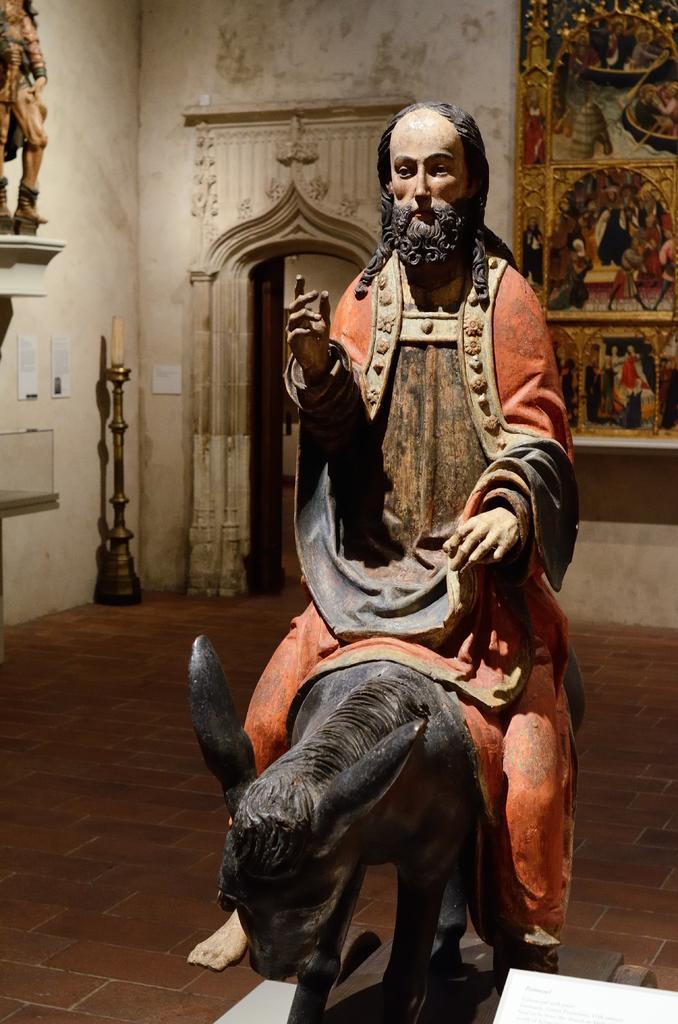How would you summarize this image in a sentence or two? In this picture we can see a statue of an animal with a person sitting on it and this statue is on the platform and in the background we can see a wall and some objects. 